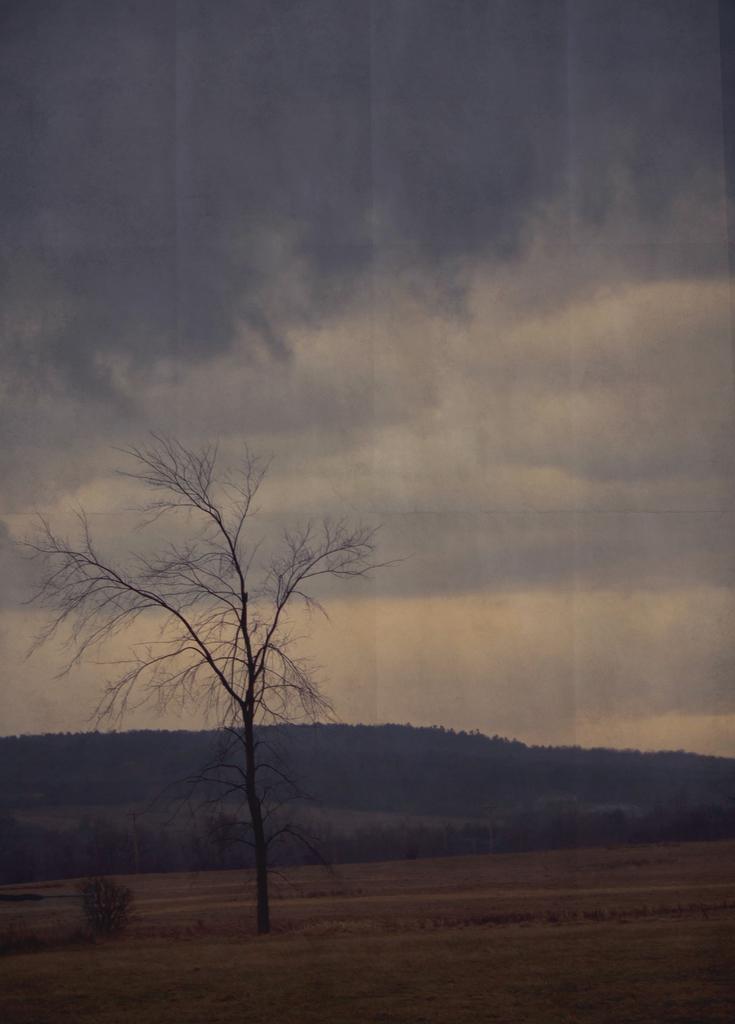Can you describe this image briefly? In this image we can see a tree, grassland, plants, hills and sky with clouds in the background. 